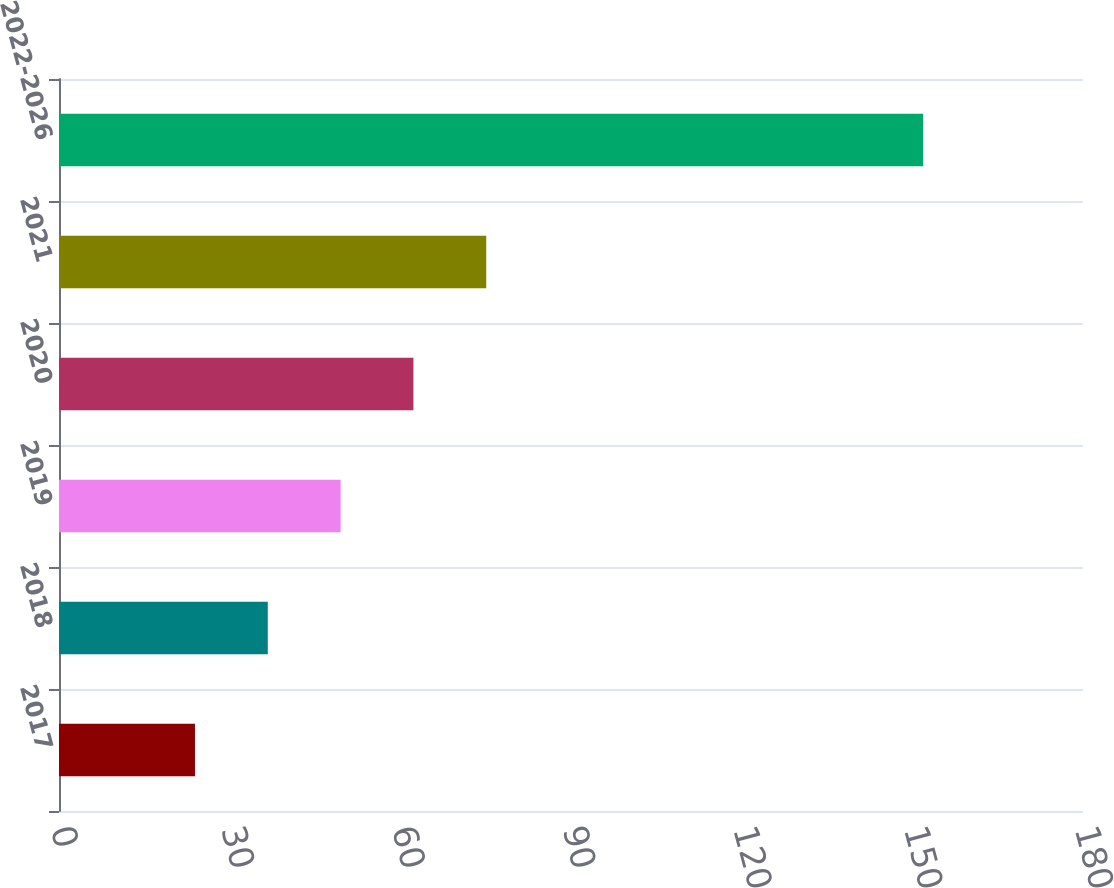<chart> <loc_0><loc_0><loc_500><loc_500><bar_chart><fcel>2017<fcel>2018<fcel>2019<fcel>2020<fcel>2021<fcel>2022-2026<nl><fcel>23.9<fcel>36.7<fcel>49.5<fcel>62.3<fcel>75.1<fcel>151.9<nl></chart> 